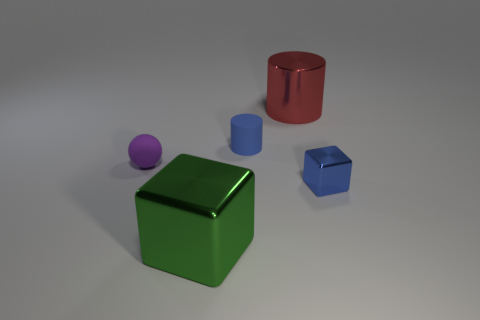What shape is the big metal object that is on the right side of the blue rubber cylinder?
Provide a succinct answer. Cylinder. Is the material of the small cube the same as the tiny ball?
Offer a very short reply. No. What is the material of the big green object that is the same shape as the blue metallic thing?
Your answer should be compact. Metal. Is the number of things that are behind the tiny metal thing less than the number of big red shiny blocks?
Provide a short and direct response. No. How many purple objects are behind the tiny blue rubber cylinder?
Keep it short and to the point. 0. There is a blue object that is in front of the matte ball; is it the same shape as the matte thing that is left of the green metallic cube?
Provide a short and direct response. No. The thing that is both on the left side of the big red thing and in front of the purple sphere has what shape?
Offer a terse response. Cube. There is a cylinder that is made of the same material as the purple ball; what size is it?
Keep it short and to the point. Small. Are there fewer tiny metal blocks than yellow rubber blocks?
Give a very brief answer. No. There is a block that is to the left of the small blue metal cube behind the big shiny thing that is in front of the blue matte cylinder; what is its material?
Your answer should be compact. Metal. 